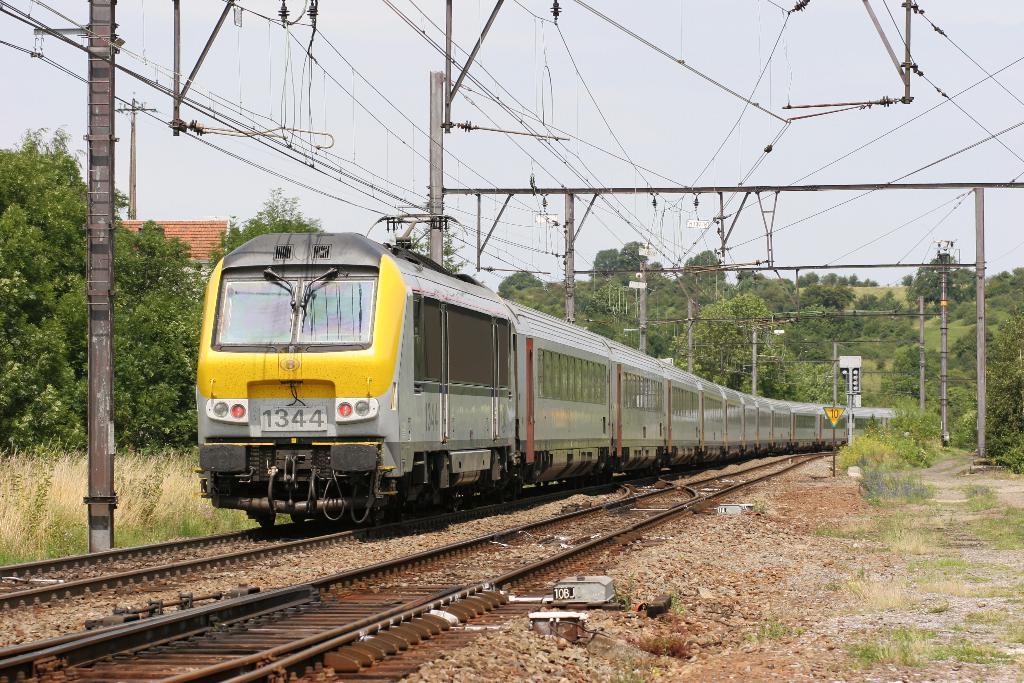Can you describe this image briefly? In this image there is a train on the railway track. At the top there are electric poles to which there are wires. At the bottom there are tracks. In between the tracks there are stones. In the background there are trees. On the right side there are poles beside the track. In the background it looks like a house. At the top there is the sky. 